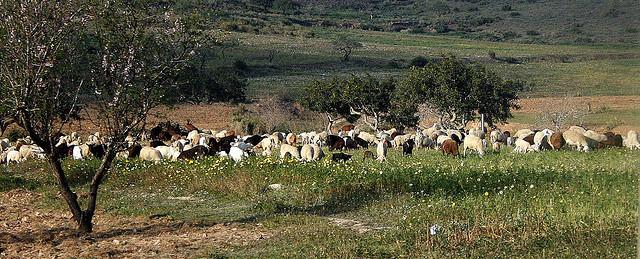What are the animals walking on?
Concise answer only. Grass. Was this photo taken in the Wild?
Be succinct. Yes. Where are the animals grazing?
Be succinct. Field. Did the sheep not notice the photographer?
Concise answer only. No. How many trees are there?
Quick response, please. 3. Where are the sheep going?
Quick response, please. Nowhere. 